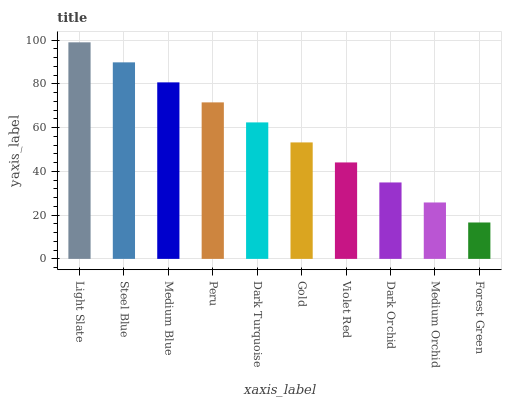Is Forest Green the minimum?
Answer yes or no. Yes. Is Light Slate the maximum?
Answer yes or no. Yes. Is Steel Blue the minimum?
Answer yes or no. No. Is Steel Blue the maximum?
Answer yes or no. No. Is Light Slate greater than Steel Blue?
Answer yes or no. Yes. Is Steel Blue less than Light Slate?
Answer yes or no. Yes. Is Steel Blue greater than Light Slate?
Answer yes or no. No. Is Light Slate less than Steel Blue?
Answer yes or no. No. Is Dark Turquoise the high median?
Answer yes or no. Yes. Is Gold the low median?
Answer yes or no. Yes. Is Medium Blue the high median?
Answer yes or no. No. Is Medium Orchid the low median?
Answer yes or no. No. 